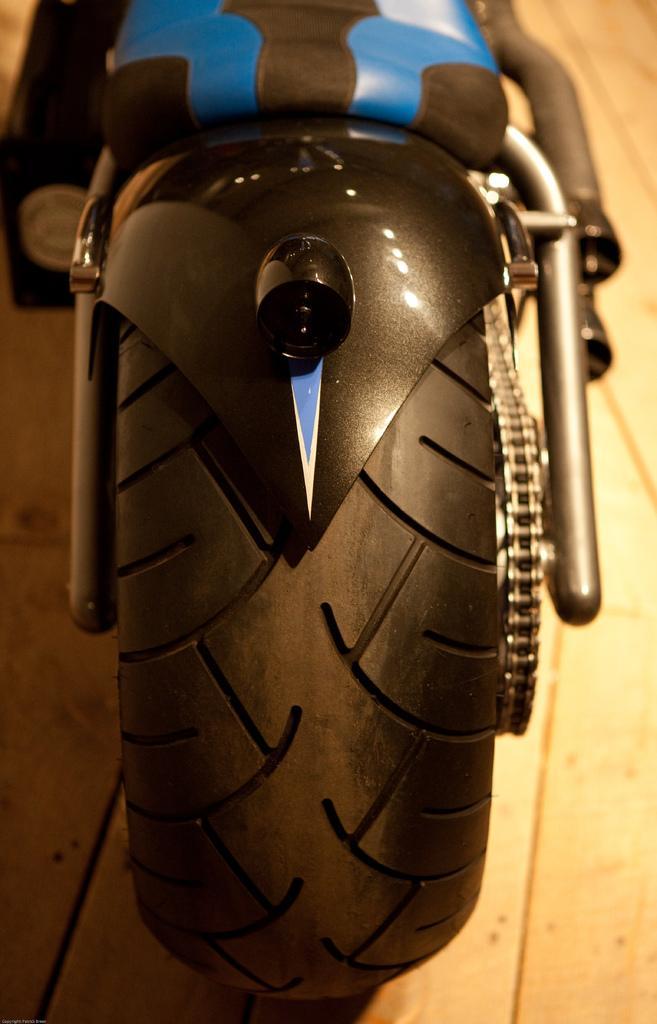Could you give a brief overview of what you see in this image? There is a bike which is having black color wheel and a chain on a surface. And the background is blurred. 